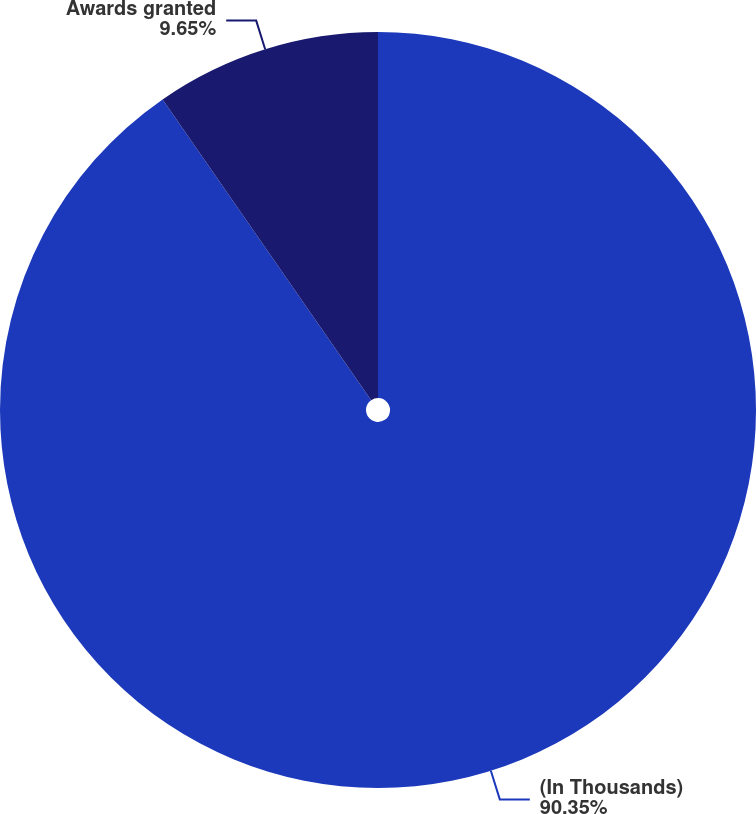Convert chart to OTSL. <chart><loc_0><loc_0><loc_500><loc_500><pie_chart><fcel>(In Thousands)<fcel>Awards granted<nl><fcel>90.35%<fcel>9.65%<nl></chart> 